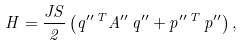Convert formula to latex. <formula><loc_0><loc_0><loc_500><loc_500>H = \frac { J S } { 2 } \left ( q ^ { \prime \prime \, T } { A } ^ { \prime \prime } \, q ^ { \prime \prime } + p ^ { \prime \prime \, T } \, p ^ { \prime \prime } \right ) ,</formula> 